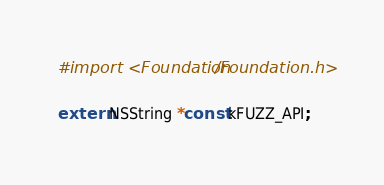Convert code to text. <code><loc_0><loc_0><loc_500><loc_500><_C_>
#import <Foundation/Foundation.h>

extern NSString *const kFUZZ_API;</code> 